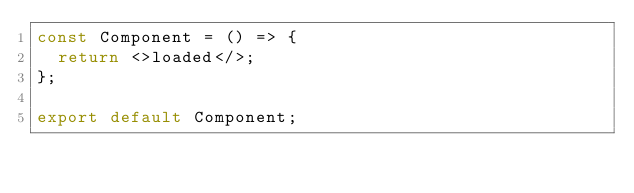Convert code to text. <code><loc_0><loc_0><loc_500><loc_500><_TypeScript_>const Component = () => {
  return <>loaded</>;
};

export default Component;
</code> 